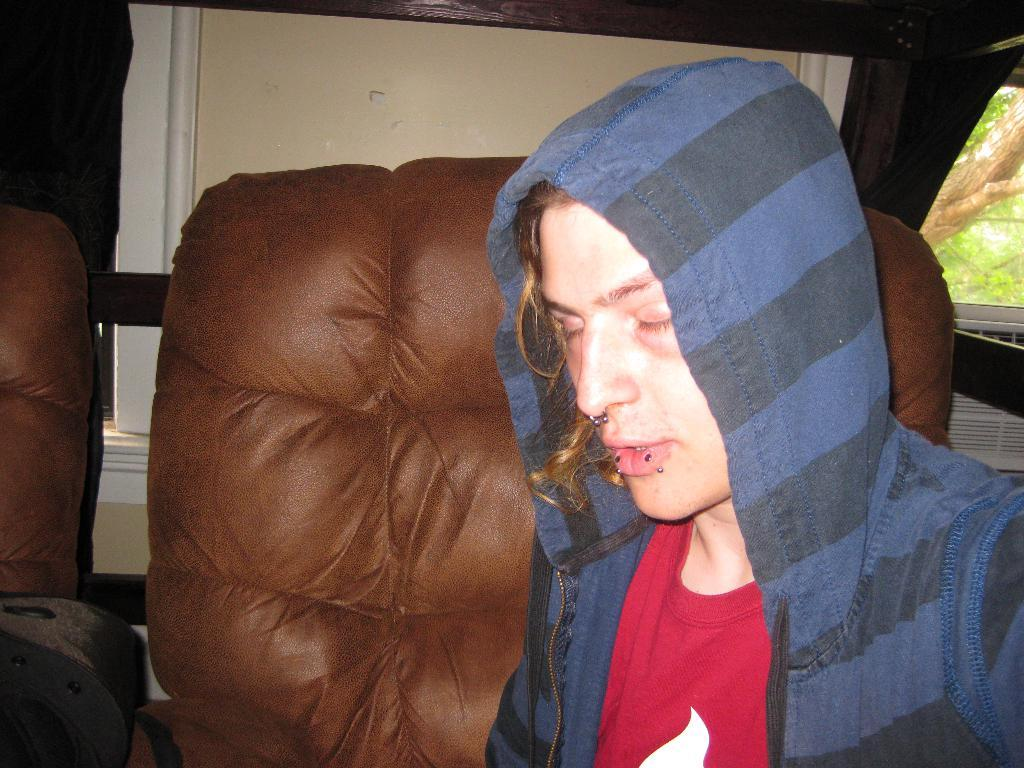Who is present in the image? There is a man in the image. What furniture is visible behind the man? There are two sofas behind the man. Where is the window located in the image? There is a window on the right side of the image. What can be seen outside the window? There is a tree visible behind the window. What type of bun is the man holding in the image? There is no bun present in the image. What is the value of the sofas in the image? The value of the sofas cannot be determined from the image alone. 